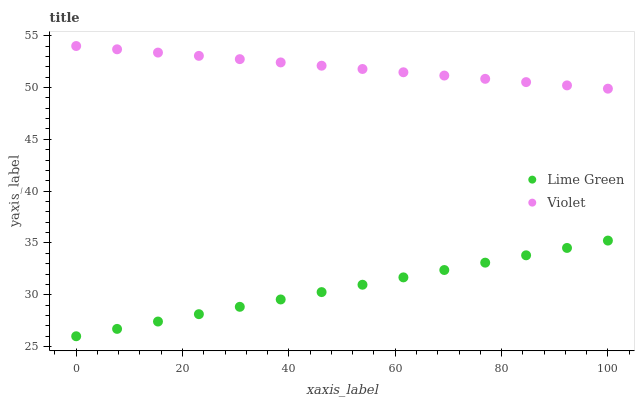Does Lime Green have the minimum area under the curve?
Answer yes or no. Yes. Does Violet have the maximum area under the curve?
Answer yes or no. Yes. Does Violet have the minimum area under the curve?
Answer yes or no. No. Is Lime Green the smoothest?
Answer yes or no. Yes. Is Violet the roughest?
Answer yes or no. Yes. Is Violet the smoothest?
Answer yes or no. No. Does Lime Green have the lowest value?
Answer yes or no. Yes. Does Violet have the lowest value?
Answer yes or no. No. Does Violet have the highest value?
Answer yes or no. Yes. Is Lime Green less than Violet?
Answer yes or no. Yes. Is Violet greater than Lime Green?
Answer yes or no. Yes. Does Lime Green intersect Violet?
Answer yes or no. No. 